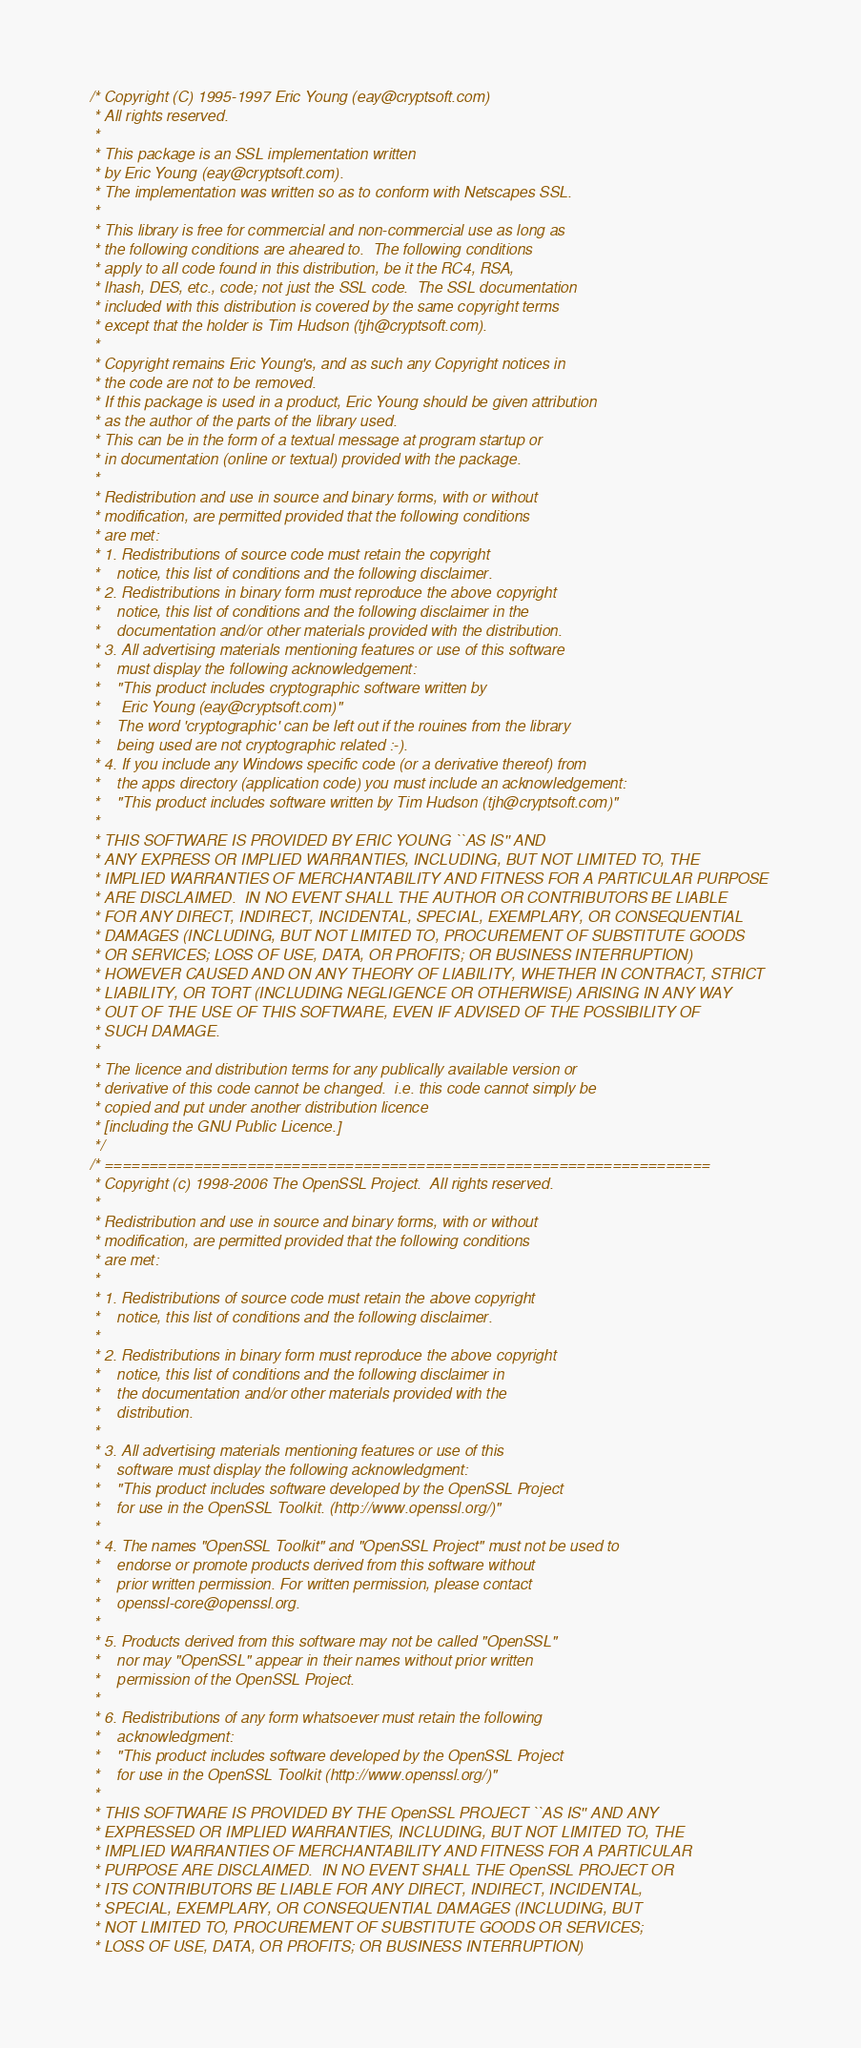Convert code to text. <code><loc_0><loc_0><loc_500><loc_500><_C_>/* Copyright (C) 1995-1997 Eric Young (eay@cryptsoft.com)
 * All rights reserved.
 *
 * This package is an SSL implementation written
 * by Eric Young (eay@cryptsoft.com).
 * The implementation was written so as to conform with Netscapes SSL.
 *
 * This library is free for commercial and non-commercial use as long as
 * the following conditions are aheared to.  The following conditions
 * apply to all code found in this distribution, be it the RC4, RSA,
 * lhash, DES, etc., code; not just the SSL code.  The SSL documentation
 * included with this distribution is covered by the same copyright terms
 * except that the holder is Tim Hudson (tjh@cryptsoft.com).
 *
 * Copyright remains Eric Young's, and as such any Copyright notices in
 * the code are not to be removed.
 * If this package is used in a product, Eric Young should be given attribution
 * as the author of the parts of the library used.
 * This can be in the form of a textual message at program startup or
 * in documentation (online or textual) provided with the package.
 *
 * Redistribution and use in source and binary forms, with or without
 * modification, are permitted provided that the following conditions
 * are met:
 * 1. Redistributions of source code must retain the copyright
 *    notice, this list of conditions and the following disclaimer.
 * 2. Redistributions in binary form must reproduce the above copyright
 *    notice, this list of conditions and the following disclaimer in the
 *    documentation and/or other materials provided with the distribution.
 * 3. All advertising materials mentioning features or use of this software
 *    must display the following acknowledgement:
 *    "This product includes cryptographic software written by
 *     Eric Young (eay@cryptsoft.com)"
 *    The word 'cryptographic' can be left out if the rouines from the library
 *    being used are not cryptographic related :-).
 * 4. If you include any Windows specific code (or a derivative thereof) from
 *    the apps directory (application code) you must include an acknowledgement:
 *    "This product includes software written by Tim Hudson (tjh@cryptsoft.com)"
 *
 * THIS SOFTWARE IS PROVIDED BY ERIC YOUNG ``AS IS'' AND
 * ANY EXPRESS OR IMPLIED WARRANTIES, INCLUDING, BUT NOT LIMITED TO, THE
 * IMPLIED WARRANTIES OF MERCHANTABILITY AND FITNESS FOR A PARTICULAR PURPOSE
 * ARE DISCLAIMED.  IN NO EVENT SHALL THE AUTHOR OR CONTRIBUTORS BE LIABLE
 * FOR ANY DIRECT, INDIRECT, INCIDENTAL, SPECIAL, EXEMPLARY, OR CONSEQUENTIAL
 * DAMAGES (INCLUDING, BUT NOT LIMITED TO, PROCUREMENT OF SUBSTITUTE GOODS
 * OR SERVICES; LOSS OF USE, DATA, OR PROFITS; OR BUSINESS INTERRUPTION)
 * HOWEVER CAUSED AND ON ANY THEORY OF LIABILITY, WHETHER IN CONTRACT, STRICT
 * LIABILITY, OR TORT (INCLUDING NEGLIGENCE OR OTHERWISE) ARISING IN ANY WAY
 * OUT OF THE USE OF THIS SOFTWARE, EVEN IF ADVISED OF THE POSSIBILITY OF
 * SUCH DAMAGE.
 *
 * The licence and distribution terms for any publically available version or
 * derivative of this code cannot be changed.  i.e. this code cannot simply be
 * copied and put under another distribution licence
 * [including the GNU Public Licence.]
 */
/* ====================================================================
 * Copyright (c) 1998-2006 The OpenSSL Project.  All rights reserved.
 *
 * Redistribution and use in source and binary forms, with or without
 * modification, are permitted provided that the following conditions
 * are met:
 *
 * 1. Redistributions of source code must retain the above copyright
 *    notice, this list of conditions and the following disclaimer.
 *
 * 2. Redistributions in binary form must reproduce the above copyright
 *    notice, this list of conditions and the following disclaimer in
 *    the documentation and/or other materials provided with the
 *    distribution.
 *
 * 3. All advertising materials mentioning features or use of this
 *    software must display the following acknowledgment:
 *    "This product includes software developed by the OpenSSL Project
 *    for use in the OpenSSL Toolkit. (http://www.openssl.org/)"
 *
 * 4. The names "OpenSSL Toolkit" and "OpenSSL Project" must not be used to
 *    endorse or promote products derived from this software without
 *    prior written permission. For written permission, please contact
 *    openssl-core@openssl.org.
 *
 * 5. Products derived from this software may not be called "OpenSSL"
 *    nor may "OpenSSL" appear in their names without prior written
 *    permission of the OpenSSL Project.
 *
 * 6. Redistributions of any form whatsoever must retain the following
 *    acknowledgment:
 *    "This product includes software developed by the OpenSSL Project
 *    for use in the OpenSSL Toolkit (http://www.openssl.org/)"
 *
 * THIS SOFTWARE IS PROVIDED BY THE OpenSSL PROJECT ``AS IS'' AND ANY
 * EXPRESSED OR IMPLIED WARRANTIES, INCLUDING, BUT NOT LIMITED TO, THE
 * IMPLIED WARRANTIES OF MERCHANTABILITY AND FITNESS FOR A PARTICULAR
 * PURPOSE ARE DISCLAIMED.  IN NO EVENT SHALL THE OpenSSL PROJECT OR
 * ITS CONTRIBUTORS BE LIABLE FOR ANY DIRECT, INDIRECT, INCIDENTAL,
 * SPECIAL, EXEMPLARY, OR CONSEQUENTIAL DAMAGES (INCLUDING, BUT
 * NOT LIMITED TO, PROCUREMENT OF SUBSTITUTE GOODS OR SERVICES;
 * LOSS OF USE, DATA, OR PROFITS; OR BUSINESS INTERRUPTION)</code> 